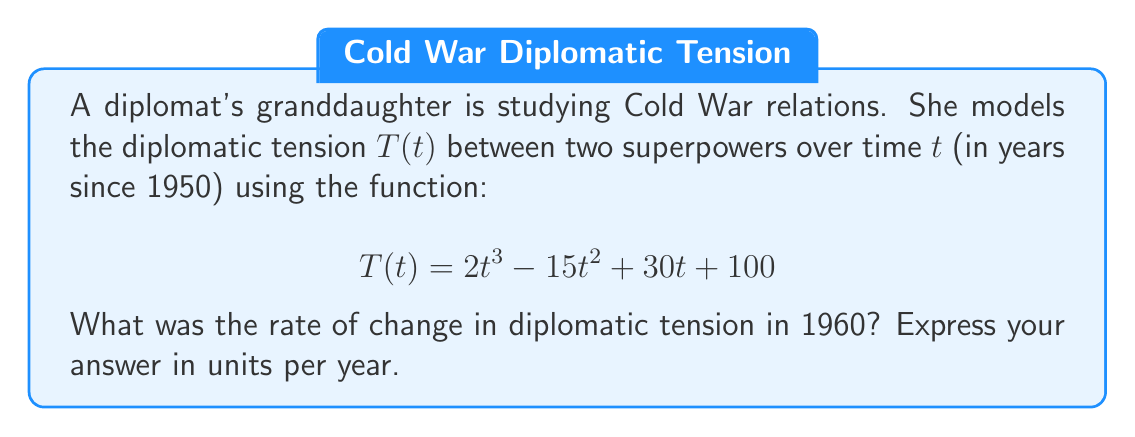What is the answer to this math problem? To find the rate of change in diplomatic tension in 1960, we need to:

1. Find the derivative of $T(t)$ to get the rate of change function.
2. Evaluate the derivative at $t = 10$ (since 1960 is 10 years after 1950).

Step 1: Find the derivative of $T(t)$
$$\begin{align}
T(t) &= 2t^3 - 15t^2 + 30t + 100 \\
T'(t) &= 6t^2 - 30t + 30
\end{align}$$

Step 2: Evaluate $T'(t)$ at $t = 10$
$$\begin{align}
T'(10) &= 6(10)^2 - 30(10) + 30 \\
&= 6(100) - 300 + 30 \\
&= 600 - 300 + 30 \\
&= 330
\end{align}$$

Therefore, the rate of change in diplomatic tension in 1960 was 330 units per year.
Answer: 330 units/year 